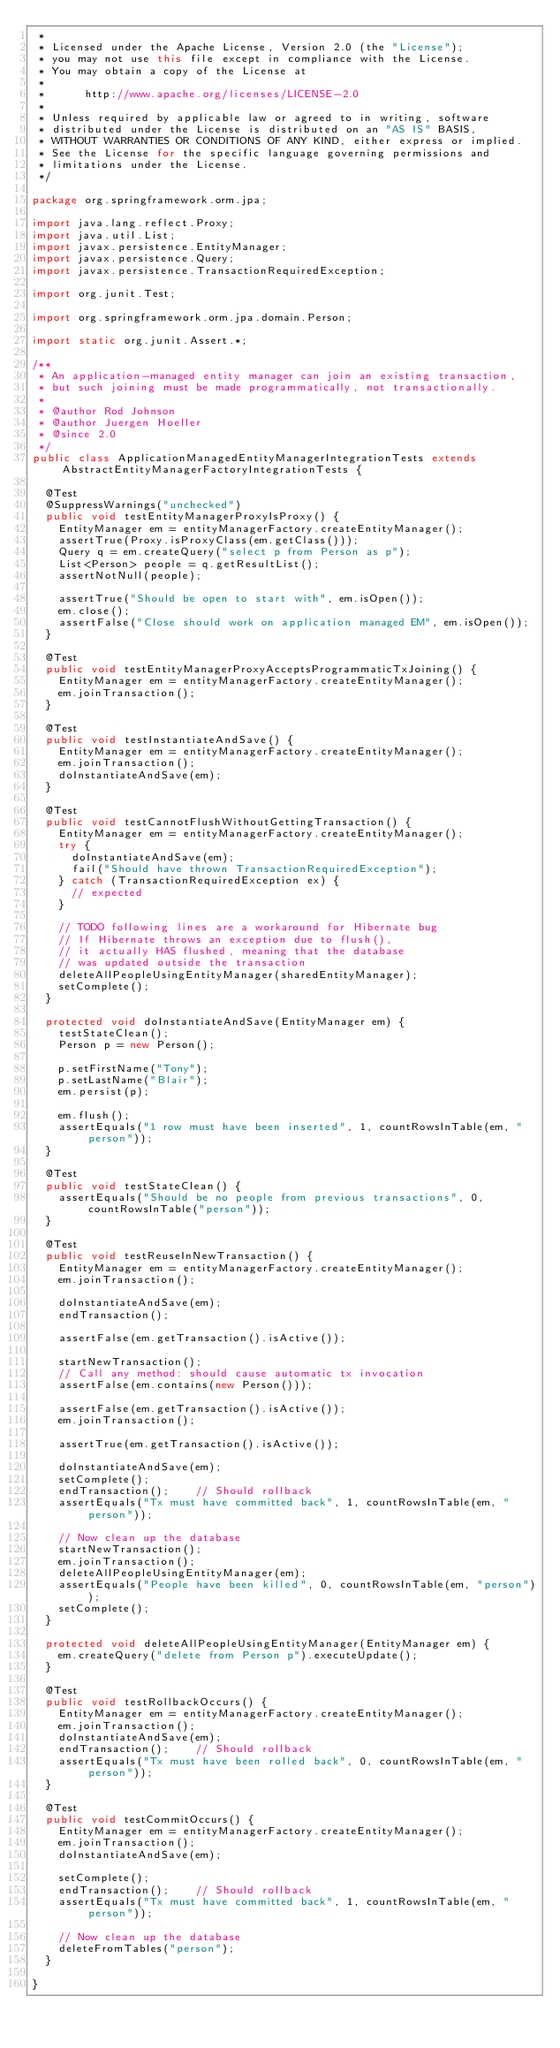<code> <loc_0><loc_0><loc_500><loc_500><_Java_> *
 * Licensed under the Apache License, Version 2.0 (the "License");
 * you may not use this file except in compliance with the License.
 * You may obtain a copy of the License at
 *
 *      http://www.apache.org/licenses/LICENSE-2.0
 *
 * Unless required by applicable law or agreed to in writing, software
 * distributed under the License is distributed on an "AS IS" BASIS,
 * WITHOUT WARRANTIES OR CONDITIONS OF ANY KIND, either express or implied.
 * See the License for the specific language governing permissions and
 * limitations under the License.
 */

package org.springframework.orm.jpa;

import java.lang.reflect.Proxy;
import java.util.List;
import javax.persistence.EntityManager;
import javax.persistence.Query;
import javax.persistence.TransactionRequiredException;

import org.junit.Test;

import org.springframework.orm.jpa.domain.Person;

import static org.junit.Assert.*;

/**
 * An application-managed entity manager can join an existing transaction,
 * but such joining must be made programmatically, not transactionally.
 *
 * @author Rod Johnson
 * @author Juergen Hoeller
 * @since 2.0
 */
public class ApplicationManagedEntityManagerIntegrationTests extends AbstractEntityManagerFactoryIntegrationTests {

	@Test
	@SuppressWarnings("unchecked")
	public void testEntityManagerProxyIsProxy() {
		EntityManager em = entityManagerFactory.createEntityManager();
		assertTrue(Proxy.isProxyClass(em.getClass()));
		Query q = em.createQuery("select p from Person as p");
		List<Person> people = q.getResultList();
		assertNotNull(people);

		assertTrue("Should be open to start with", em.isOpen());
		em.close();
		assertFalse("Close should work on application managed EM", em.isOpen());
	}

	@Test
	public void testEntityManagerProxyAcceptsProgrammaticTxJoining() {
		EntityManager em = entityManagerFactory.createEntityManager();
		em.joinTransaction();
	}

	@Test
	public void testInstantiateAndSave() {
		EntityManager em = entityManagerFactory.createEntityManager();
		em.joinTransaction();
		doInstantiateAndSave(em);
	}

	@Test
	public void testCannotFlushWithoutGettingTransaction() {
		EntityManager em = entityManagerFactory.createEntityManager();
		try {
			doInstantiateAndSave(em);
			fail("Should have thrown TransactionRequiredException");
		} catch (TransactionRequiredException ex) {
			// expected
		}

		// TODO following lines are a workaround for Hibernate bug
		// If Hibernate throws an exception due to flush(),
		// it actually HAS flushed, meaning that the database
		// was updated outside the transaction
		deleteAllPeopleUsingEntityManager(sharedEntityManager);
		setComplete();
	}

	protected void doInstantiateAndSave(EntityManager em) {
		testStateClean();
		Person p = new Person();

		p.setFirstName("Tony");
		p.setLastName("Blair");
		em.persist(p);

		em.flush();
		assertEquals("1 row must have been inserted", 1, countRowsInTable(em, "person"));
	}

	@Test
	public void testStateClean() {
		assertEquals("Should be no people from previous transactions", 0, countRowsInTable("person"));
	}

	@Test
	public void testReuseInNewTransaction() {
		EntityManager em = entityManagerFactory.createEntityManager();
		em.joinTransaction();

		doInstantiateAndSave(em);
		endTransaction();

		assertFalse(em.getTransaction().isActive());

		startNewTransaction();
		// Call any method: should cause automatic tx invocation
		assertFalse(em.contains(new Person()));

		assertFalse(em.getTransaction().isActive());
		em.joinTransaction();

		assertTrue(em.getTransaction().isActive());

		doInstantiateAndSave(em);
		setComplete();
		endTransaction();    // Should rollback
		assertEquals("Tx must have committed back", 1, countRowsInTable(em, "person"));

		// Now clean up the database
		startNewTransaction();
		em.joinTransaction();
		deleteAllPeopleUsingEntityManager(em);
		assertEquals("People have been killed", 0, countRowsInTable(em, "person"));
		setComplete();
	}

	protected void deleteAllPeopleUsingEntityManager(EntityManager em) {
		em.createQuery("delete from Person p").executeUpdate();
	}

	@Test
	public void testRollbackOccurs() {
		EntityManager em = entityManagerFactory.createEntityManager();
		em.joinTransaction();
		doInstantiateAndSave(em);
		endTransaction();    // Should rollback
		assertEquals("Tx must have been rolled back", 0, countRowsInTable(em, "person"));
	}

	@Test
	public void testCommitOccurs() {
		EntityManager em = entityManagerFactory.createEntityManager();
		em.joinTransaction();
		doInstantiateAndSave(em);

		setComplete();
		endTransaction();    // Should rollback
		assertEquals("Tx must have committed back", 1, countRowsInTable(em, "person"));

		// Now clean up the database
		deleteFromTables("person");
	}

}
</code> 